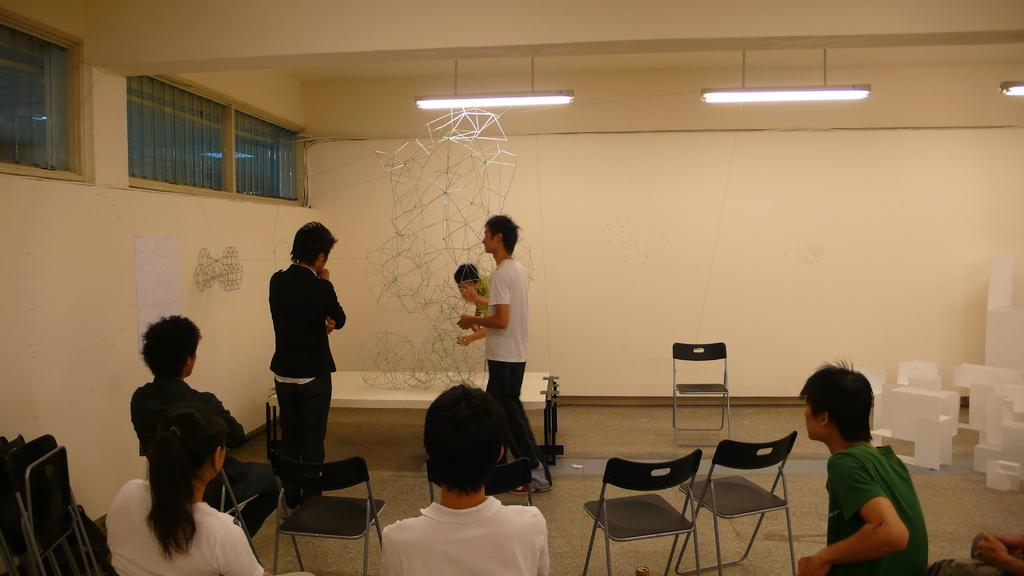How many people are sitting in the image? There are 5 persons sitting on chairs in the image. How many people are standing in the image? There are 3 persons standing in the image. Can you describe the lighting in the image? There are 3 lights on the ceiling and the wall in the image. What is on the wall in the image? There is a paper on the wall in the image. What type of ground can be seen beneath the people in the image? There is no ground visible in the image, as it appears to be an indoor setting. How many cows are present in the image? There are no cows present in the image. 